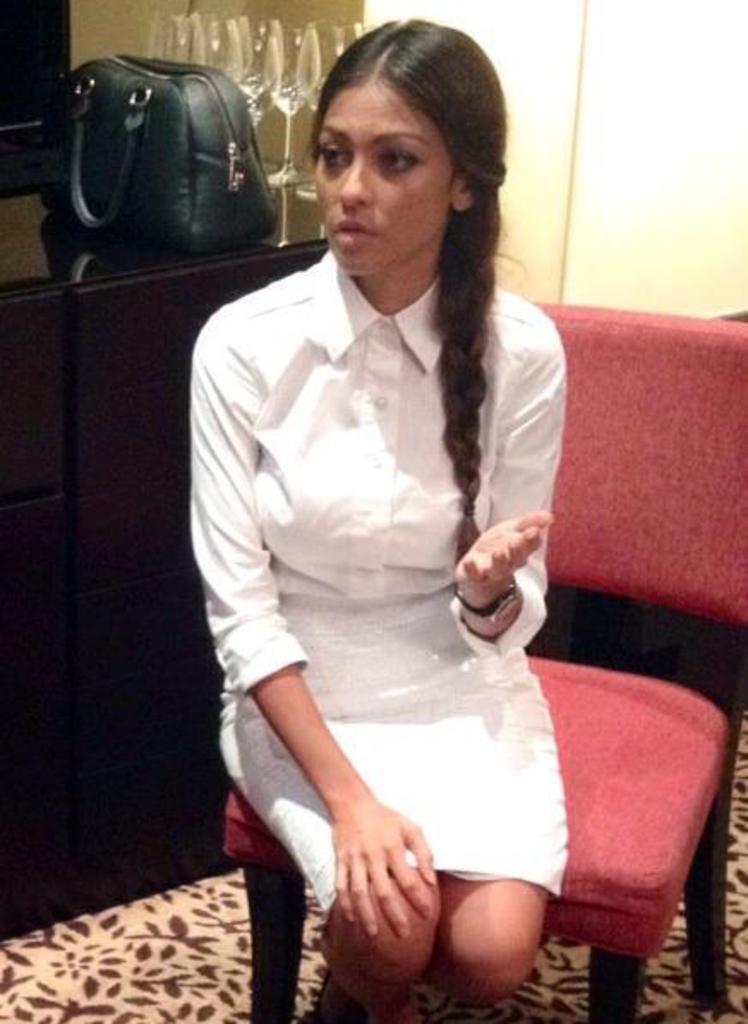Describe this image in one or two sentences. This image consists of a woman wearing a white dress. She is sitting in a chair. On the left, there is a cabinet on which a bag is kept. And there are wine glasses kept on the desk. 